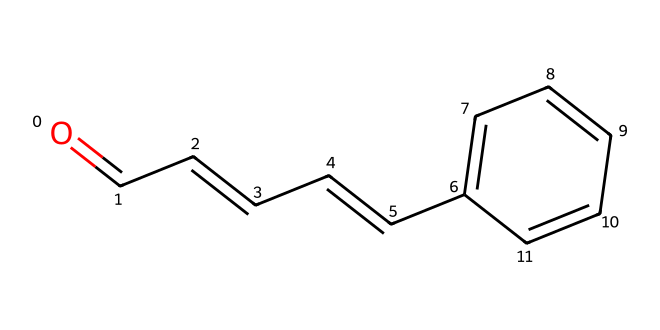What is the molecular formula of cinnamaldehyde? By analyzing the SMILES representation, we count the number of carbon (C), hydrogen (H), and oxygen (O) atoms. There are 9 carbons, 8 hydrogens, and 1 oxygen. Therefore, the molecular formula is C9H8O.
Answer: C9H8O How many double bonds are present in the chemical structure? In the SMILES, we look for "=" signs which indicate double bonds. There are four "=" signs, meaning there are four double bonds in the structure.
Answer: 4 What type of functional group is found in cinnamaldehyde? The "O=" in the structure denotes the presence of a carbonyl group (C=O), typical for aldehydes where this group is at the end of the carbon chain. Hence, the functional group is an aldehyde.
Answer: aldehyde Does cinnamaldehyde have any rings in its structure? Looking at the SMILES, there is a "C1" which indicates the start of a ring structure, and it's followed by "C1" again which confirms that the ring closes there. Thus, it contains a ring.
Answer: yes What is the significance of the carbonyl group in aldehydes like cinnamaldehyde? The carbonyl group (C=O) is crucial for aldehydes as it influences their reactivity and contributes to characteristics like smell. It is this group that classifies it as an aldehyde and chemically directs reactions.
Answer: reactivity and smell How does the structure influence the aromatic properties of cinnamaldehyde? The aromatic ring (indicated by the presence of C=C bonds) contributes to strong, pleasant smells typical of cinnamaldehyde. The unique arrangement allows for electron delocalization, enhancing its aromatic qualities.
Answer: aromatic properties What does the presence of the alkene indicate about cinnamaldehyde’s structure? The presence of C=C bonds, shown in the SMILES, indicates that cinnamaldehyde has unsaturation. This contributes to its chemical properties, enhancing stability and reactivity, integral to aldehydes.
Answer: unsaturation 